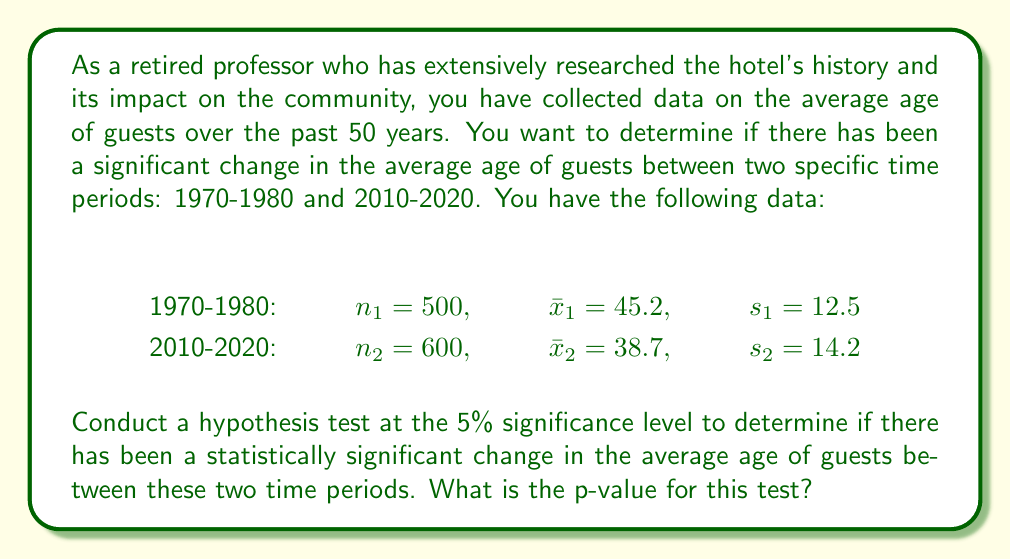Help me with this question. To determine if there has been a statistically significant change in the average age of guests, we'll use a two-sample t-test for independent samples. We'll follow these steps:

1. Set up the hypotheses:
   $H_0: \mu_1 = \mu_2$ (null hypothesis: no difference in average ages)
   $H_1: \mu_1 \neq \mu_2$ (alternative hypothesis: there is a difference in average ages)

2. Calculate the pooled standard error:
   $$SE = \sqrt{\frac{s_1^2}{n_1} + \frac{s_2^2}{n_2}}$$
   $$SE = \sqrt{\frac{12.5^2}{500} + \frac{14.2^2}{600}} = \sqrt{0.3125 + 0.3361} = \sqrt{0.6486} = 0.8054$$

3. Calculate the t-statistic:
   $$t = \frac{\bar{x}_1 - \bar{x}_2}{SE} = \frac{45.2 - 38.7}{0.8054} = 8.0706$$

4. Calculate the degrees of freedom (df):
   We'll use the conservative approach and take the smaller of $n_1 - 1$ and $n_2 - 1$:
   $df = min(500 - 1, 600 - 1) = 499$

5. Find the p-value:
   For a two-tailed test with df = 499 and t = 8.0706, we need to find:
   $p = 2 * P(T > |8.0706|)$, where T follows a t-distribution with 499 degrees of freedom.

   Using a t-distribution calculator or statistical software, we find:
   $p < 0.0001$

The p-value is extremely small (less than 0.0001), which is much less than our significance level of 0.05.
Answer: The p-value for this test is $p < 0.0001$. This extremely small p-value provides strong evidence to reject the null hypothesis. We can conclude that there is a statistically significant difference in the average age of guests between the 1970-1980 and 2010-2020 time periods. 